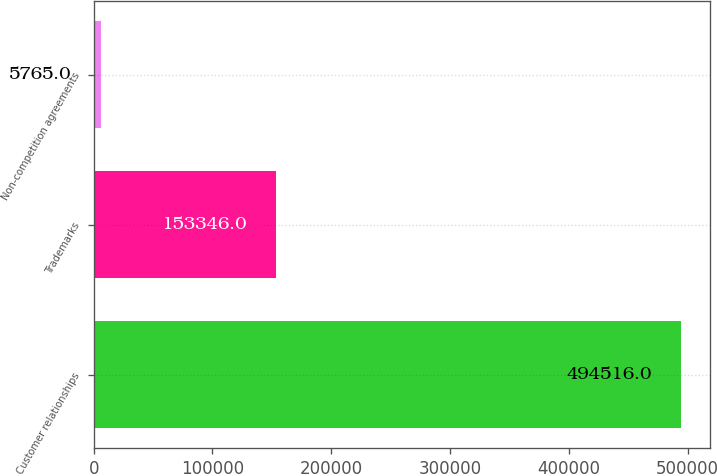<chart> <loc_0><loc_0><loc_500><loc_500><bar_chart><fcel>Customer relationships<fcel>Trademarks<fcel>Non-competition agreements<nl><fcel>494516<fcel>153346<fcel>5765<nl></chart> 